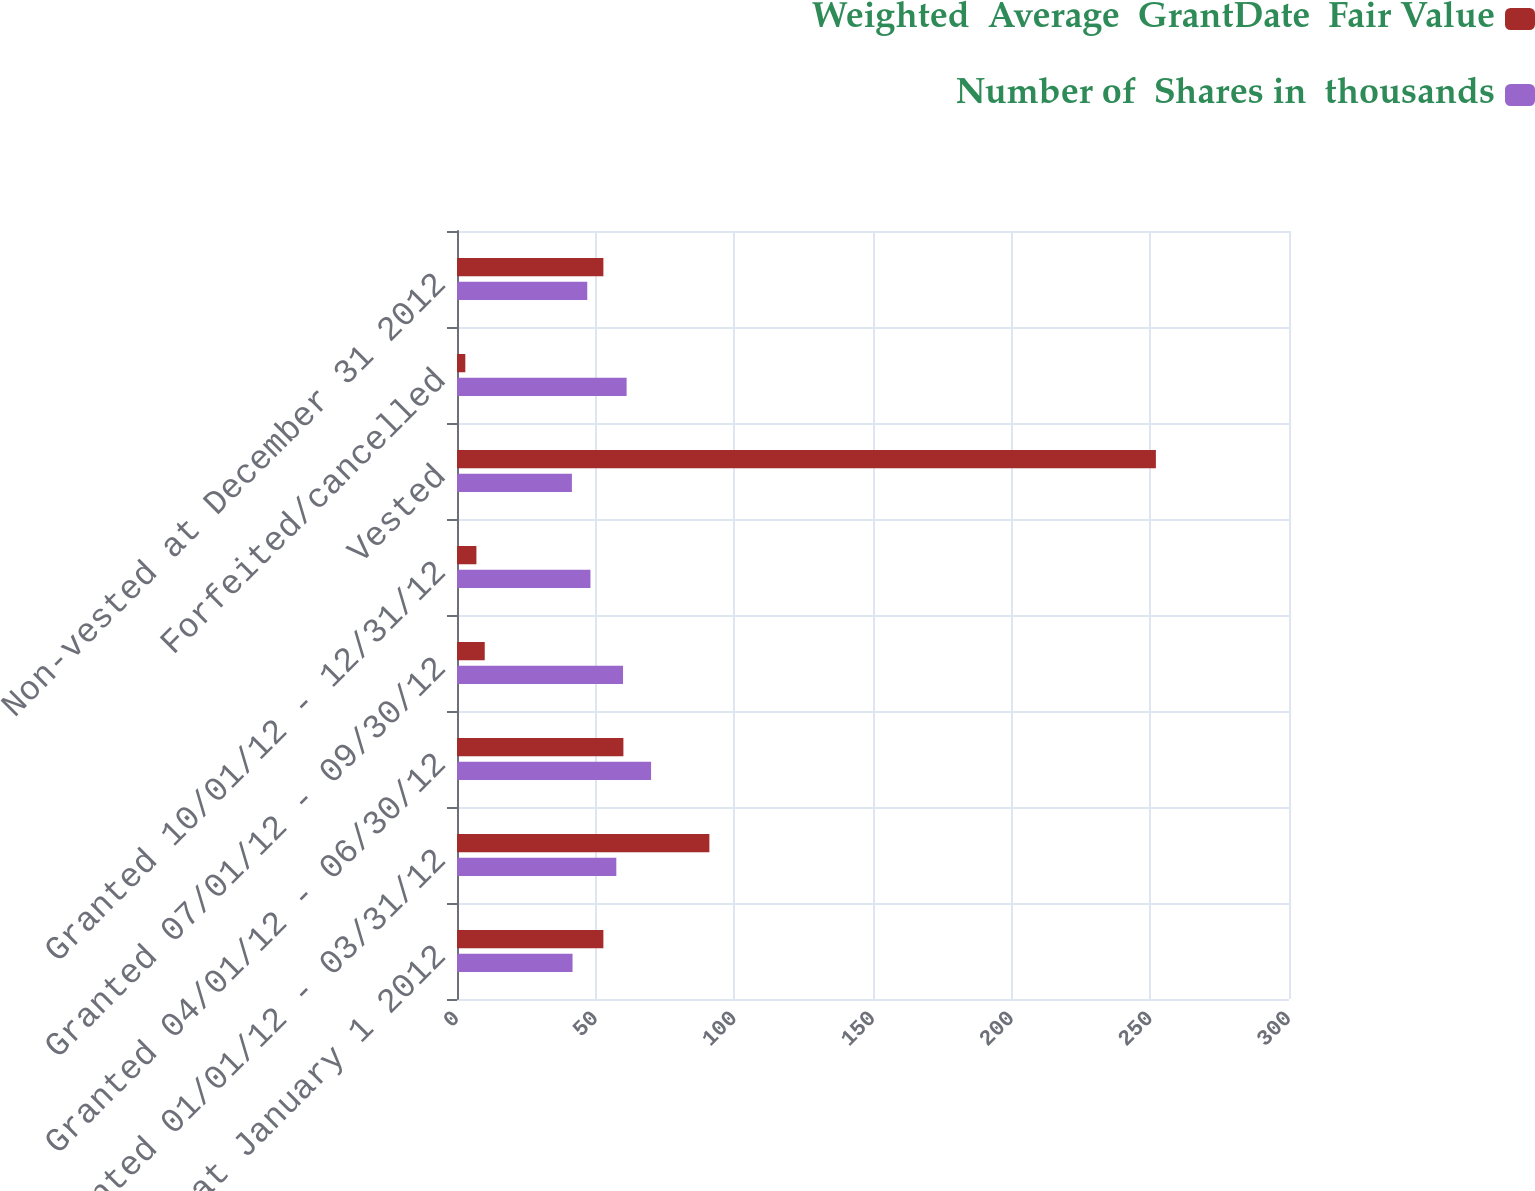Convert chart to OTSL. <chart><loc_0><loc_0><loc_500><loc_500><stacked_bar_chart><ecel><fcel>Non-vested at January 1 2012<fcel>Granted 01/01/12 - 03/31/12<fcel>Granted 04/01/12 - 06/30/12<fcel>Granted 07/01/12 - 09/30/12<fcel>Granted 10/01/12 - 12/31/12<fcel>Vested<fcel>Forfeited/cancelled<fcel>Non-vested at December 31 2012<nl><fcel>Weighted  Average  GrantDate  Fair Value<fcel>52.785<fcel>91<fcel>60<fcel>10<fcel>7<fcel>252<fcel>3<fcel>52.785<nl><fcel>Number of  Shares in  thousands<fcel>41.66<fcel>57.45<fcel>69.98<fcel>59.87<fcel>48.12<fcel>41.43<fcel>61.16<fcel>46.97<nl></chart> 